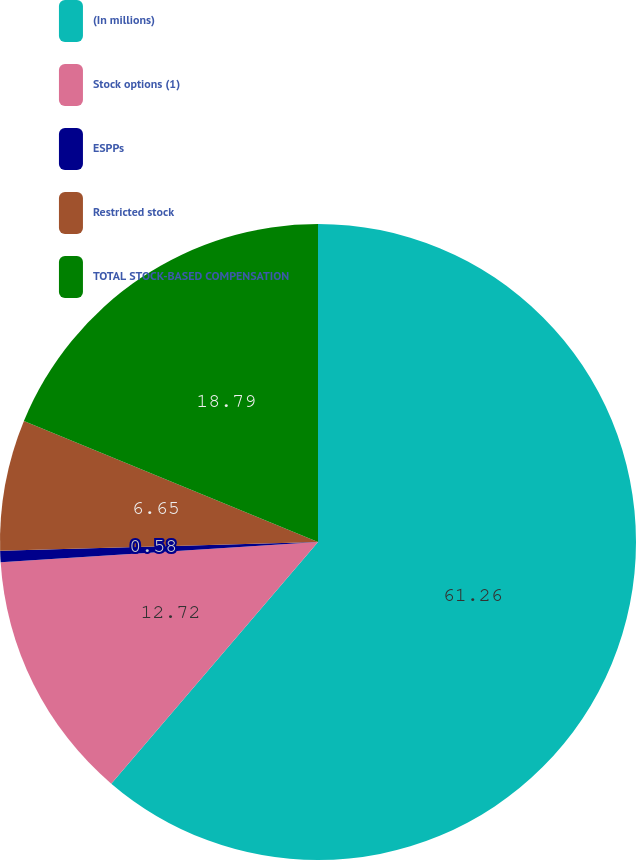<chart> <loc_0><loc_0><loc_500><loc_500><pie_chart><fcel>(In millions)<fcel>Stock options (1)<fcel>ESPPs<fcel>Restricted stock<fcel>TOTAL STOCK-BASED COMPENSATION<nl><fcel>61.27%<fcel>12.72%<fcel>0.58%<fcel>6.65%<fcel>18.79%<nl></chart> 